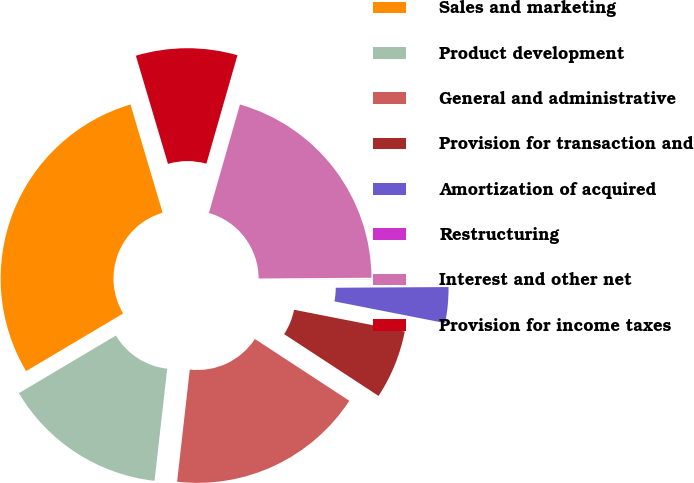<chart> <loc_0><loc_0><loc_500><loc_500><pie_chart><fcel>Sales and marketing<fcel>Product development<fcel>General and administrative<fcel>Provision for transaction and<fcel>Amortization of acquired<fcel>Restructuring<fcel>Interest and other net<fcel>Provision for income taxes<nl><fcel>28.94%<fcel>14.68%<fcel>17.57%<fcel>6.14%<fcel>3.18%<fcel>0.01%<fcel>20.46%<fcel>9.03%<nl></chart> 